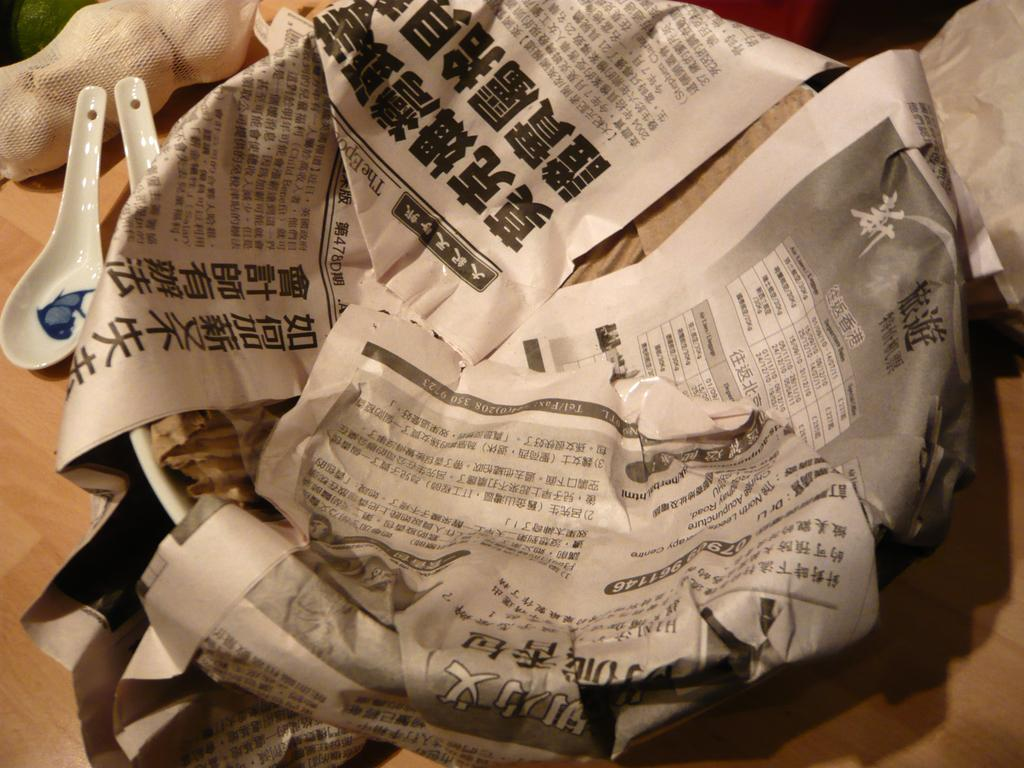What type of surface is visible in the image? There is a wooden surface in the image. What objects are placed on the wooden surface? There are spoons on the wooden surface. How is the garlic stored in the image? The garlic is in a net cover. What is the condition of the plate in the image? The plate is wrapped in papers. What type of operation is being performed on the wooden surface in the image? There is no operation being performed on the wooden surface in the image. Can you see a rake in the image? There is no rake present in the image. 